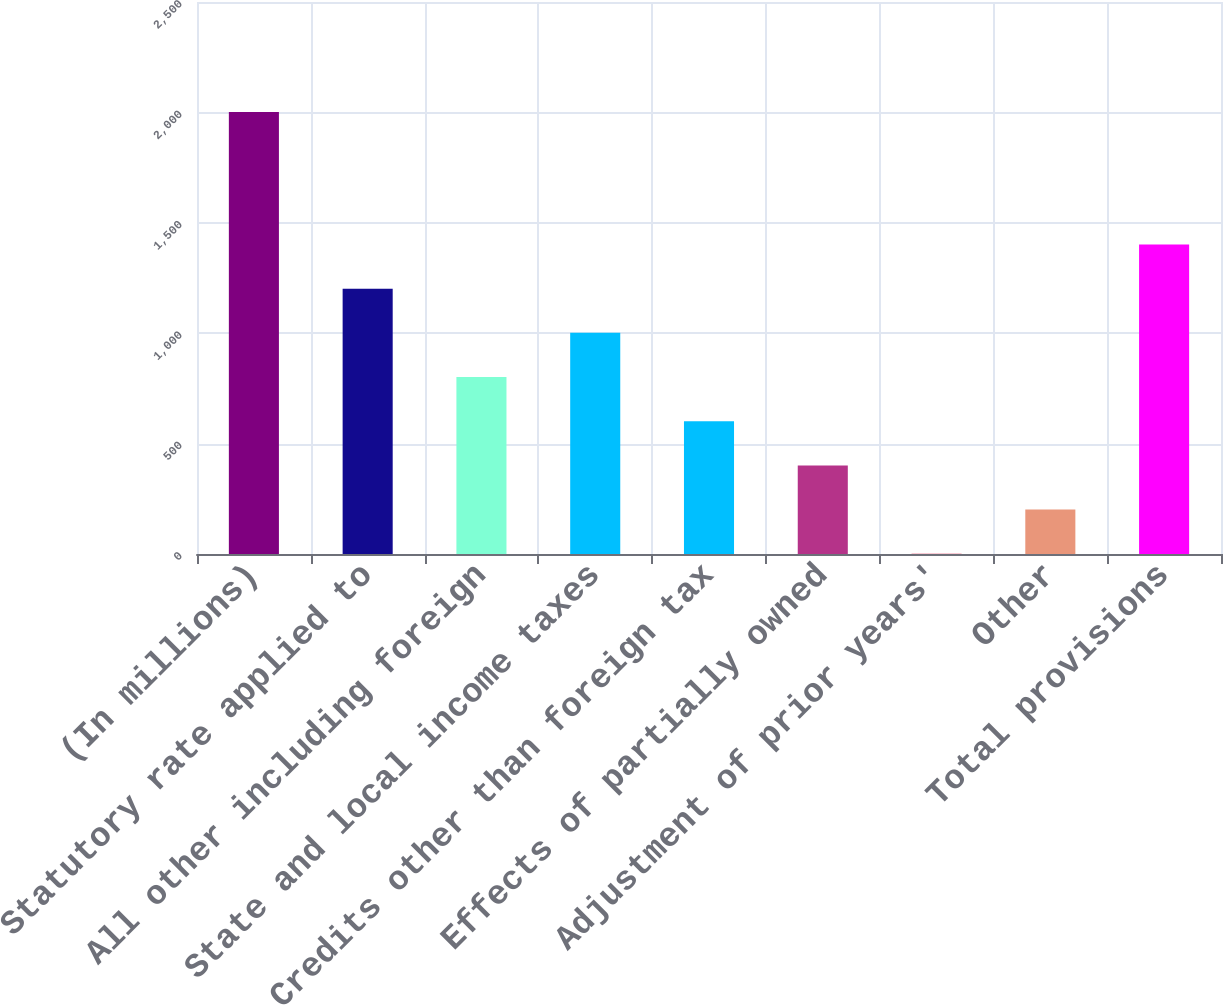<chart> <loc_0><loc_0><loc_500><loc_500><bar_chart><fcel>(In millions)<fcel>Statutory rate applied to<fcel>All other including foreign<fcel>State and local income taxes<fcel>Credits other than foreign tax<fcel>Effects of partially owned<fcel>Adjustment of prior years'<fcel>Other<fcel>Total provisions<nl><fcel>2002<fcel>1201.6<fcel>801.4<fcel>1001.5<fcel>601.3<fcel>401.2<fcel>1<fcel>201.1<fcel>1401.7<nl></chart> 